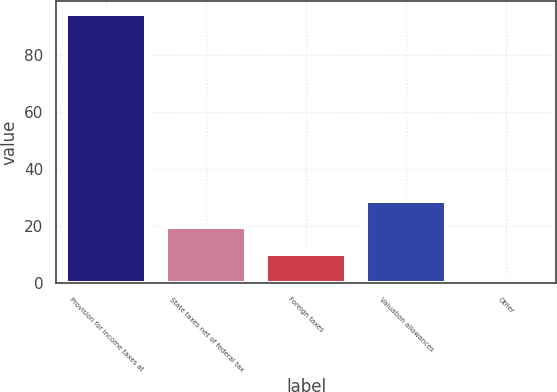Convert chart. <chart><loc_0><loc_0><loc_500><loc_500><bar_chart><fcel>Provision for income taxes at<fcel>State taxes net of federal tax<fcel>Foreign taxes<fcel>Valuation allowances<fcel>Other<nl><fcel>94.4<fcel>19.6<fcel>10.25<fcel>28.95<fcel>0.9<nl></chart> 